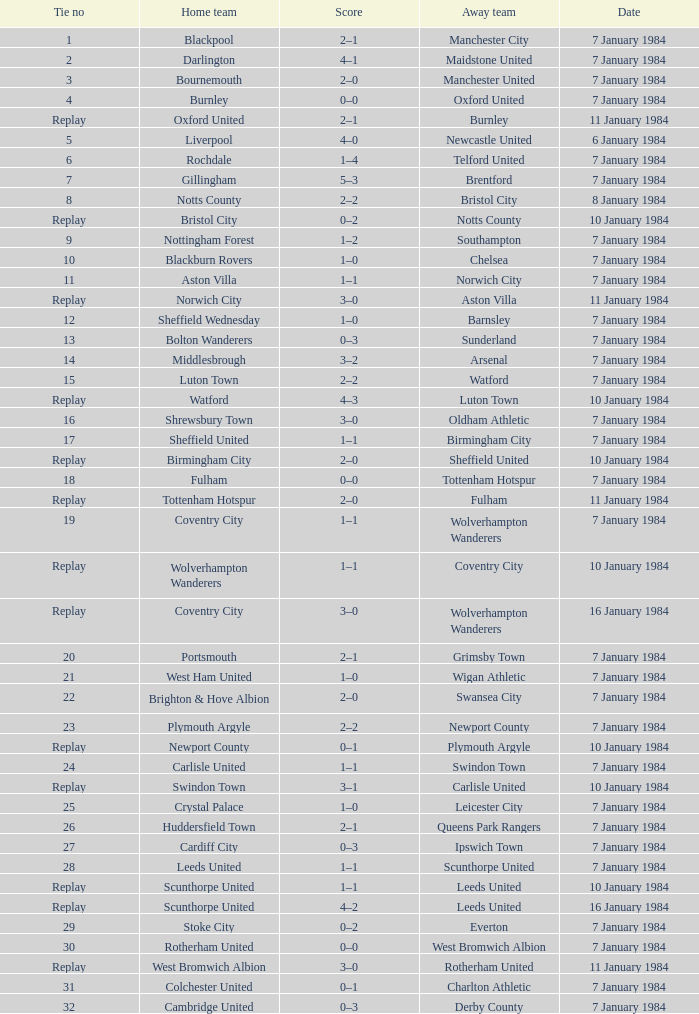Who was the away team with a tie of 14? Arsenal. 